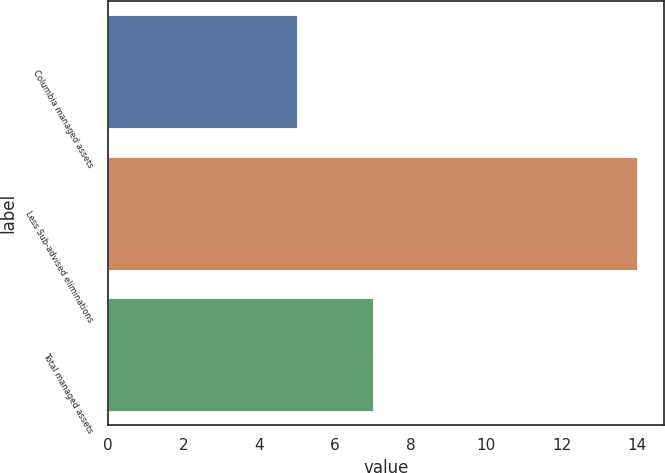Convert chart. <chart><loc_0><loc_0><loc_500><loc_500><bar_chart><fcel>Columbia managed assets<fcel>Less Sub-advised eliminations<fcel>Total managed assets<nl><fcel>5<fcel>14<fcel>7<nl></chart> 